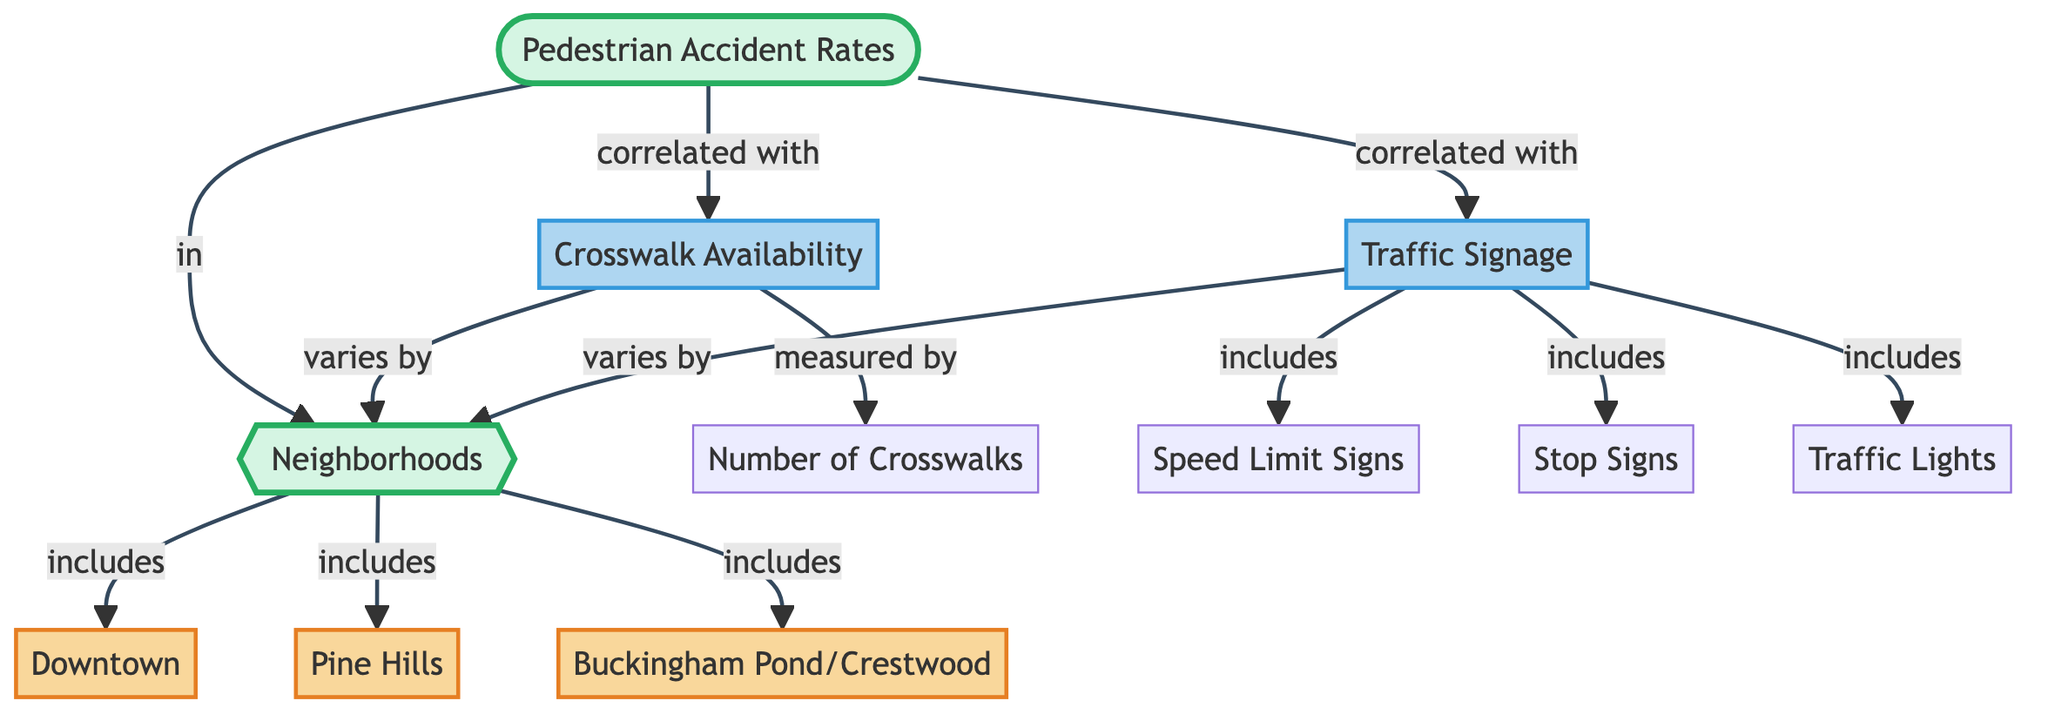What is the main concept represented in the diagram? The diagram's main concept is represented by the node labeled "Pedestrian Accident Rates," which is central in the flowchart and connects to other elements.
Answer: Pedestrian Accident Rates Which neighborhoods are included in the diagram? The neighborhoods mentioned in the diagram are explicitly connected to the main concept of pedestrian accident rates and include "Downtown," "Pine Hills," and "Buckingham Pond/Crestwood."
Answer: Downtown, Pine Hills, Buckingham Pond/Crestwood How does crosswalk availability vary? Crosswalk availability is indicated in the diagram as varying by neighborhoods, meaning the number of crosswalks differs depending on which neighborhood you are in.
Answer: By neighborhoods What types of traffic signage are included in the diagram? The types of traffic signage represented in the diagram include speed limit signs, stop signs, and traffic lights, which are specifically listed under the traffic signage component.
Answer: Speed limit signs, stop signs, traffic lights How is pedestrian accidents correlated with crosswalk availability? The diagram illustrates a direct correlation between pedestrian accidents and crosswalk availability, indicating that as the availability of crosswalks changes, so do the rates of pedestrian accidents in the neighborhoods.
Answer: Correlated How many factors are influencing pedestrian accident rates in the diagram? The diagram outlines two main factors that influence pedestrian accident rates: traffic signage and crosswalk availability, both of which connect to the pedestrian accidents node.
Answer: Two factors Which factor has a direct correlation with pedestrian accident rates? Both traffic signage and crosswalk availability are indicated to have a direct correlation with pedestrian accident rates, as shown in the connections made in the diagram.
Answer: Both traffic signage and crosswalk availability What does the term 'measured by' refer to in context of crosswalk availability? The term 'measured by' in relation to crosswalk availability indicates that the availability is assessed by counting the number of crosswalks present in different neighborhoods.
Answer: Number of crosswalks What do the neighborhoods correlate with in regards to accidents? The neighborhoods are correlated with both the crosswalk availability and traffic signage, suggesting that the safety features in each neighborhood relate directly to pedestrian accident rates.
Answer: Traffic signage and crosswalk availability 